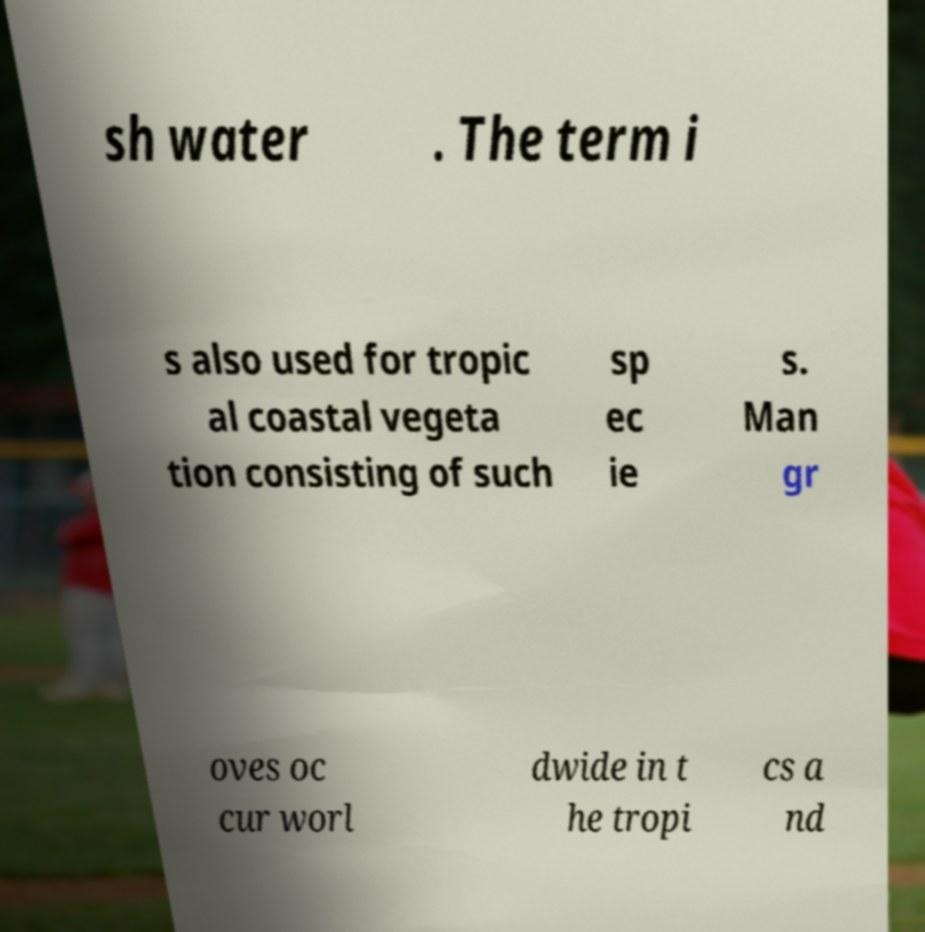I need the written content from this picture converted into text. Can you do that? sh water . The term i s also used for tropic al coastal vegeta tion consisting of such sp ec ie s. Man gr oves oc cur worl dwide in t he tropi cs a nd 